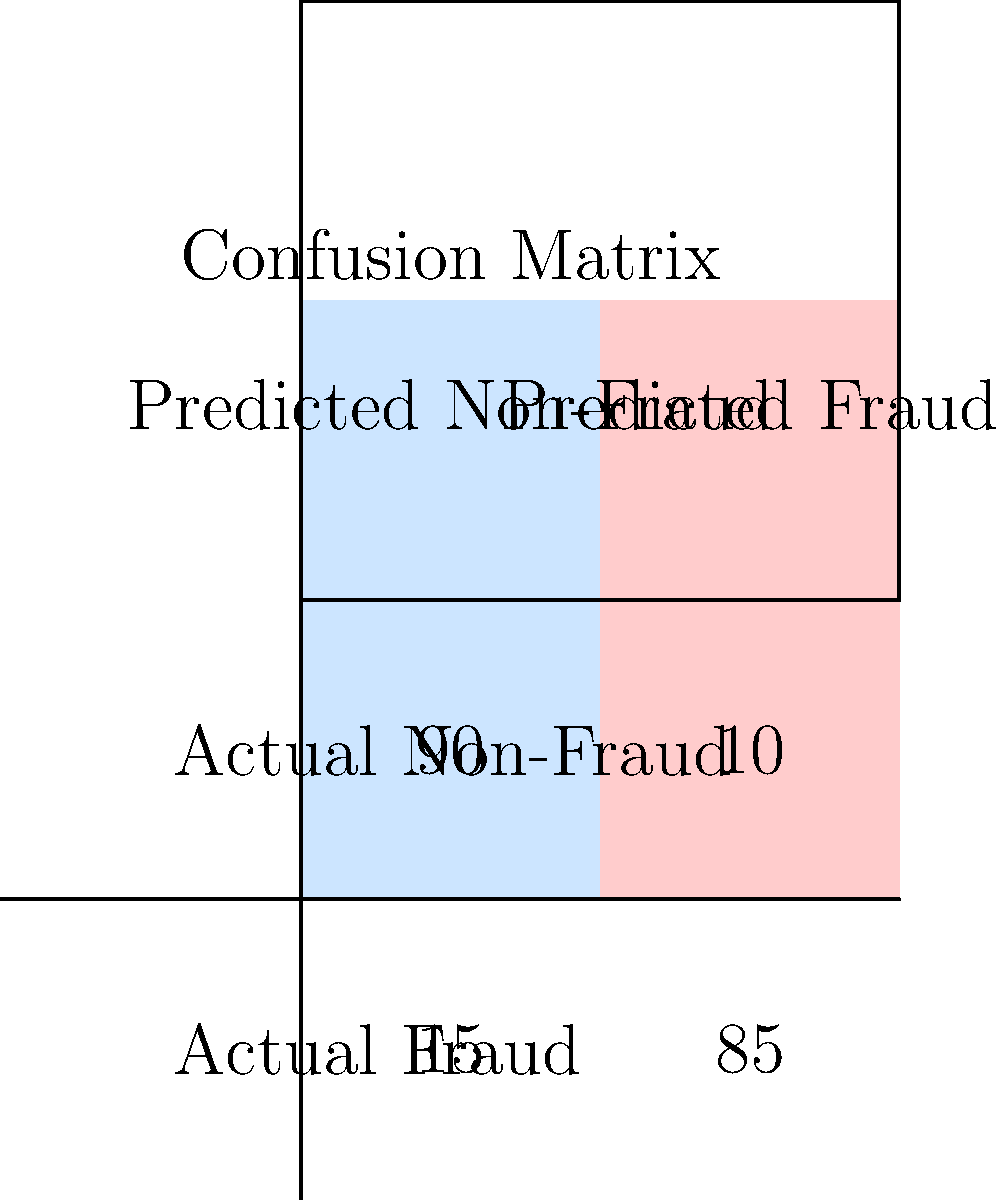As a regulatory investigator, you're evaluating a company's fraud detection model. Given the confusion matrix above, what is the precision of the fraud detection model? Express your answer as a percentage rounded to two decimal places. To calculate the precision of the fraud detection model, we need to follow these steps:

1. Understand the confusion matrix:
   - True Positives (TP): 85 (correctly identified fraud cases)
   - False Positives (FP): 10 (non-fraud cases incorrectly identified as fraud)
   - False Negatives (FN): 15 (fraud cases incorrectly identified as non-fraud)
   - True Negatives (TN): 90 (correctly identified non-fraud cases)

2. Recall the formula for precision:
   $$ \text{Precision} = \frac{\text{True Positives}}{\text{True Positives} + \text{False Positives}} $$

3. Substitute the values:
   $$ \text{Precision} = \frac{85}{85 + 10} = \frac{85}{95} $$

4. Calculate the result:
   $$ \frac{85}{95} \approx 0.8947368421 $$

5. Convert to a percentage and round to two decimal places:
   $$ 0.8947368421 \times 100\% \approx 89.47\% $$

Therefore, the precision of the fraud detection model is 89.47%.
Answer: 89.47% 